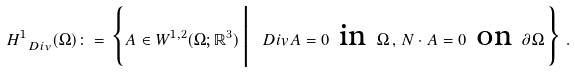Convert formula to latex. <formula><loc_0><loc_0><loc_500><loc_500>H ^ { 1 } _ { \ D i v } ( \Omega ) \colon = \Big \{ { A } \in W ^ { 1 , 2 } ( \Omega ; { \mathbb { R } } ^ { 3 } ) \, \Big | \, \ D i v { A } = 0 \text { in } \Omega \, , \, N \cdot { A } = 0 \text { on } \partial \Omega \, \Big \} \, .</formula> 